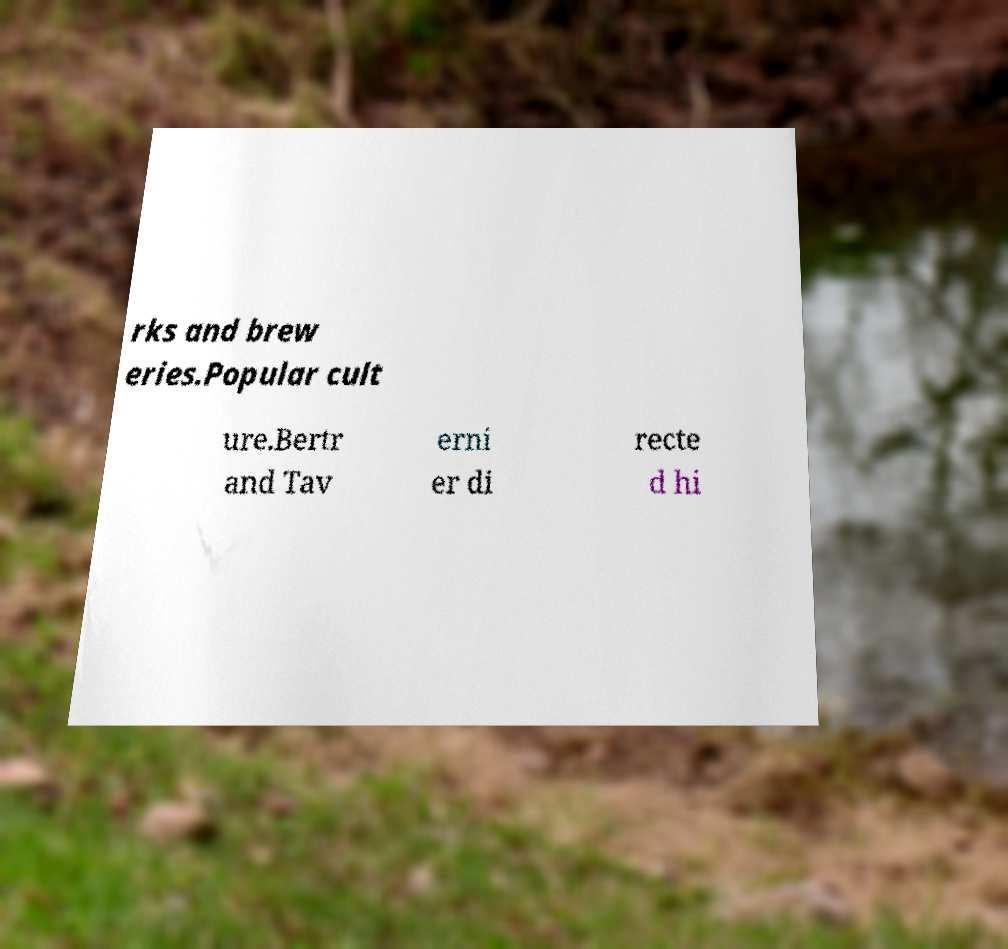What messages or text are displayed in this image? I need them in a readable, typed format. rks and brew eries.Popular cult ure.Bertr and Tav erni er di recte d hi 